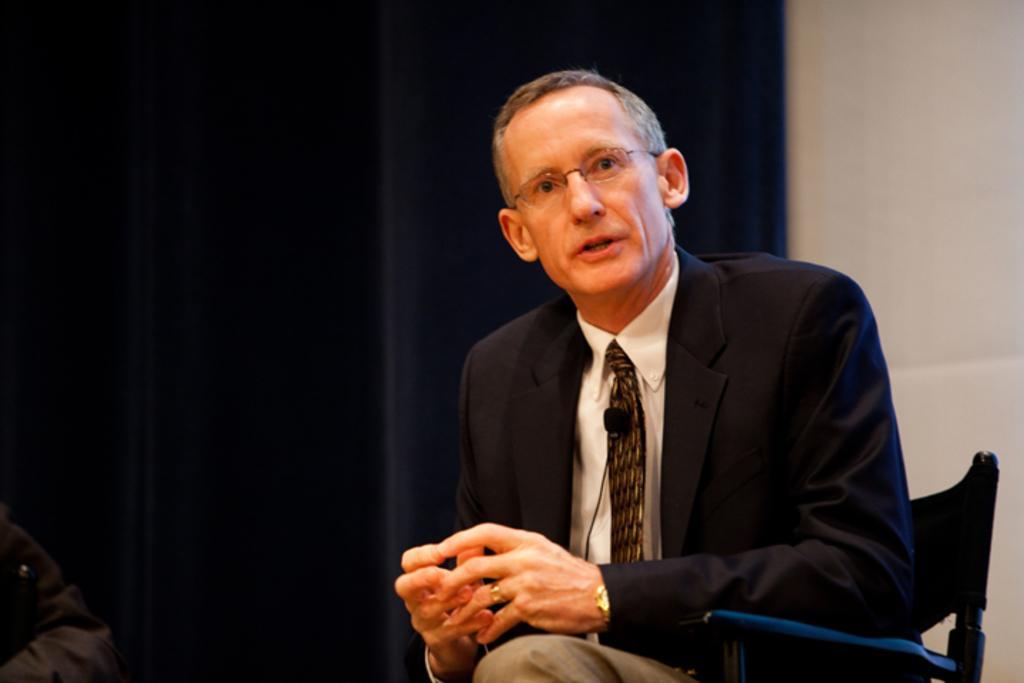Could you give a brief overview of what you see in this image? In this image i can see a man sitting on a chair he is wearing a blue blazer, white shirt, brown tie, cream pants at the back ground i can see a black curtain and a white wall. 